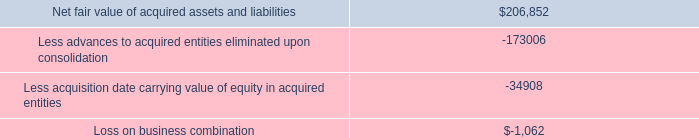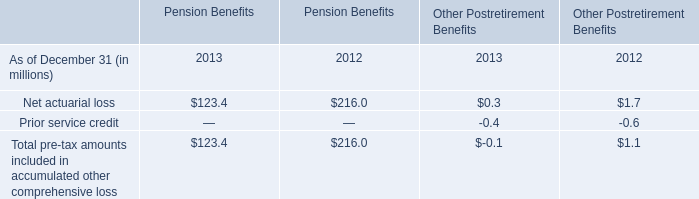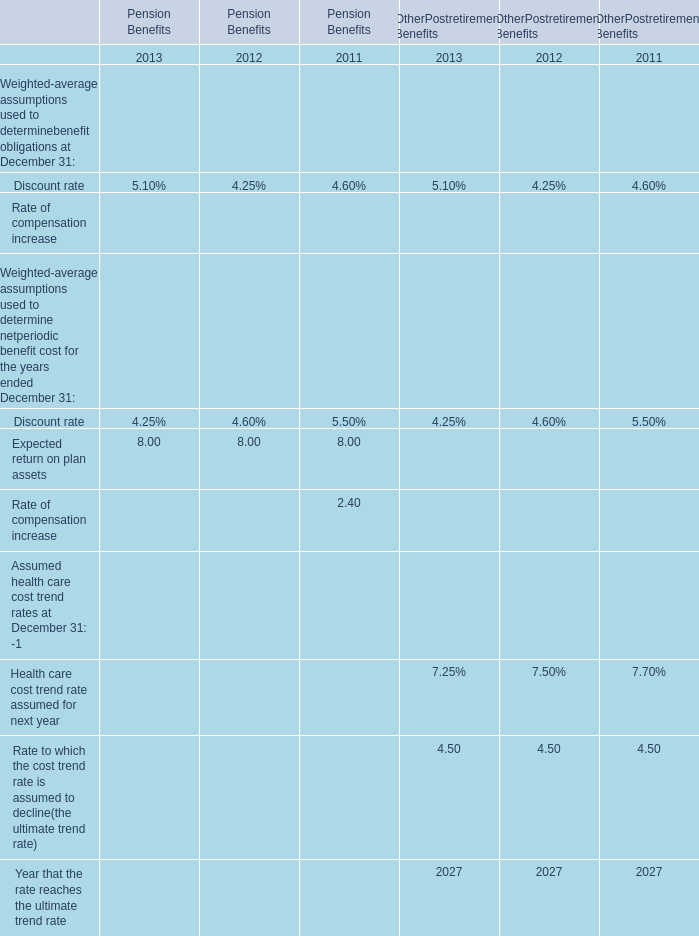Which year is the Net actuarial loss for Pension Benefits lower? 
Answer: 2013. 